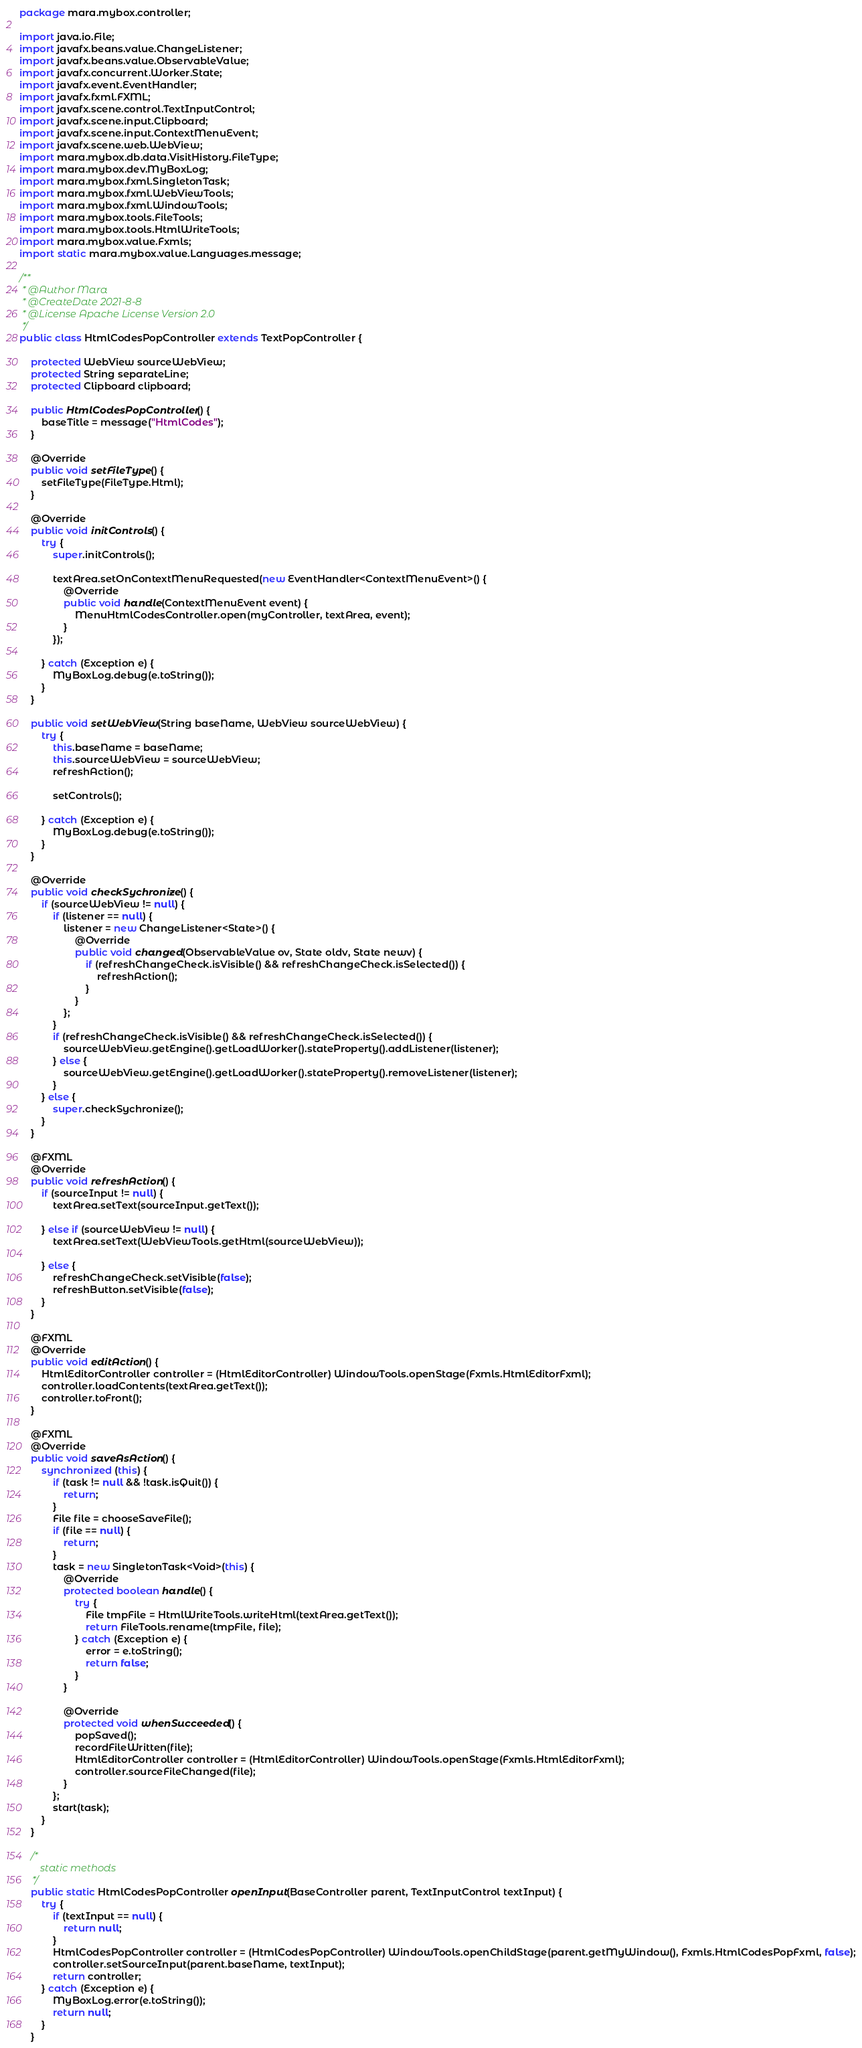Convert code to text. <code><loc_0><loc_0><loc_500><loc_500><_Java_>package mara.mybox.controller;

import java.io.File;
import javafx.beans.value.ChangeListener;
import javafx.beans.value.ObservableValue;
import javafx.concurrent.Worker.State;
import javafx.event.EventHandler;
import javafx.fxml.FXML;
import javafx.scene.control.TextInputControl;
import javafx.scene.input.Clipboard;
import javafx.scene.input.ContextMenuEvent;
import javafx.scene.web.WebView;
import mara.mybox.db.data.VisitHistory.FileType;
import mara.mybox.dev.MyBoxLog;
import mara.mybox.fxml.SingletonTask;
import mara.mybox.fxml.WebViewTools;
import mara.mybox.fxml.WindowTools;
import mara.mybox.tools.FileTools;
import mara.mybox.tools.HtmlWriteTools;
import mara.mybox.value.Fxmls;
import static mara.mybox.value.Languages.message;

/**
 * @Author Mara
 * @CreateDate 2021-8-8
 * @License Apache License Version 2.0
 */
public class HtmlCodesPopController extends TextPopController {

    protected WebView sourceWebView;
    protected String separateLine;
    protected Clipboard clipboard;

    public HtmlCodesPopController() {
        baseTitle = message("HtmlCodes");
    }

    @Override
    public void setFileType() {
        setFileType(FileType.Html);
    }

    @Override
    public void initControls() {
        try {
            super.initControls();

            textArea.setOnContextMenuRequested(new EventHandler<ContextMenuEvent>() {
                @Override
                public void handle(ContextMenuEvent event) {
                    MenuHtmlCodesController.open(myController, textArea, event);
                }
            });

        } catch (Exception e) {
            MyBoxLog.debug(e.toString());
        }
    }

    public void setWebView(String baseName, WebView sourceWebView) {
        try {
            this.baseName = baseName;
            this.sourceWebView = sourceWebView;
            refreshAction();

            setControls();

        } catch (Exception e) {
            MyBoxLog.debug(e.toString());
        }
    }

    @Override
    public void checkSychronize() {
        if (sourceWebView != null) {
            if (listener == null) {
                listener = new ChangeListener<State>() {
                    @Override
                    public void changed(ObservableValue ov, State oldv, State newv) {
                        if (refreshChangeCheck.isVisible() && refreshChangeCheck.isSelected()) {
                            refreshAction();
                        }
                    }
                };
            }
            if (refreshChangeCheck.isVisible() && refreshChangeCheck.isSelected()) {
                sourceWebView.getEngine().getLoadWorker().stateProperty().addListener(listener);
            } else {
                sourceWebView.getEngine().getLoadWorker().stateProperty().removeListener(listener);
            }
        } else {
            super.checkSychronize();
        }
    }

    @FXML
    @Override
    public void refreshAction() {
        if (sourceInput != null) {
            textArea.setText(sourceInput.getText());

        } else if (sourceWebView != null) {
            textArea.setText(WebViewTools.getHtml(sourceWebView));

        } else {
            refreshChangeCheck.setVisible(false);
            refreshButton.setVisible(false);
        }
    }

    @FXML
    @Override
    public void editAction() {
        HtmlEditorController controller = (HtmlEditorController) WindowTools.openStage(Fxmls.HtmlEditorFxml);
        controller.loadContents(textArea.getText());
        controller.toFront();
    }

    @FXML
    @Override
    public void saveAsAction() {
        synchronized (this) {
            if (task != null && !task.isQuit()) {
                return;
            }
            File file = chooseSaveFile();
            if (file == null) {
                return;
            }
            task = new SingletonTask<Void>(this) {
                @Override
                protected boolean handle() {
                    try {
                        File tmpFile = HtmlWriteTools.writeHtml(textArea.getText());
                        return FileTools.rename(tmpFile, file);
                    } catch (Exception e) {
                        error = e.toString();
                        return false;
                    }
                }

                @Override
                protected void whenSucceeded() {
                    popSaved();
                    recordFileWritten(file);
                    HtmlEditorController controller = (HtmlEditorController) WindowTools.openStage(Fxmls.HtmlEditorFxml);
                    controller.sourceFileChanged(file);
                }
            };
            start(task);
        }
    }

    /*
        static methods
     */
    public static HtmlCodesPopController openInput(BaseController parent, TextInputControl textInput) {
        try {
            if (textInput == null) {
                return null;
            }
            HtmlCodesPopController controller = (HtmlCodesPopController) WindowTools.openChildStage(parent.getMyWindow(), Fxmls.HtmlCodesPopFxml, false);
            controller.setSourceInput(parent.baseName, textInput);
            return controller;
        } catch (Exception e) {
            MyBoxLog.error(e.toString());
            return null;
        }
    }
</code> 